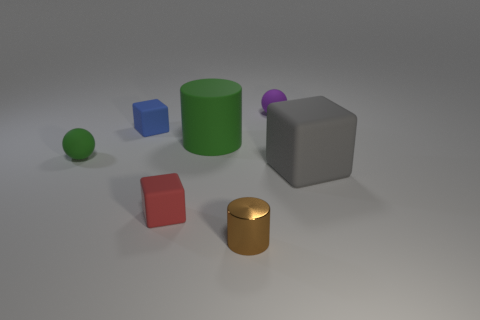There is a object that is the same color as the large rubber cylinder; what shape is it?
Offer a very short reply. Sphere. What color is the ball to the right of the large object that is to the left of the tiny brown shiny object?
Your answer should be very brief. Purple. Are there more large matte cubes than tiny cyan matte cubes?
Your answer should be very brief. Yes. How many green things have the same size as the red matte thing?
Your answer should be very brief. 1. Do the red thing and the sphere that is on the left side of the brown metal cylinder have the same material?
Keep it short and to the point. Yes. Is the number of small brown shiny cylinders less than the number of rubber balls?
Offer a terse response. Yes. Is there any other thing that has the same color as the rubber cylinder?
Make the answer very short. Yes. There is a small green thing that is made of the same material as the tiny purple sphere; what is its shape?
Offer a very short reply. Sphere. How many small brown metallic cylinders are right of the tiny rubber sphere behind the tiny matte block that is on the left side of the tiny red matte cube?
Your answer should be very brief. 0. There is a tiny matte object that is both left of the purple rubber object and on the right side of the blue block; what is its shape?
Provide a short and direct response. Cube. 